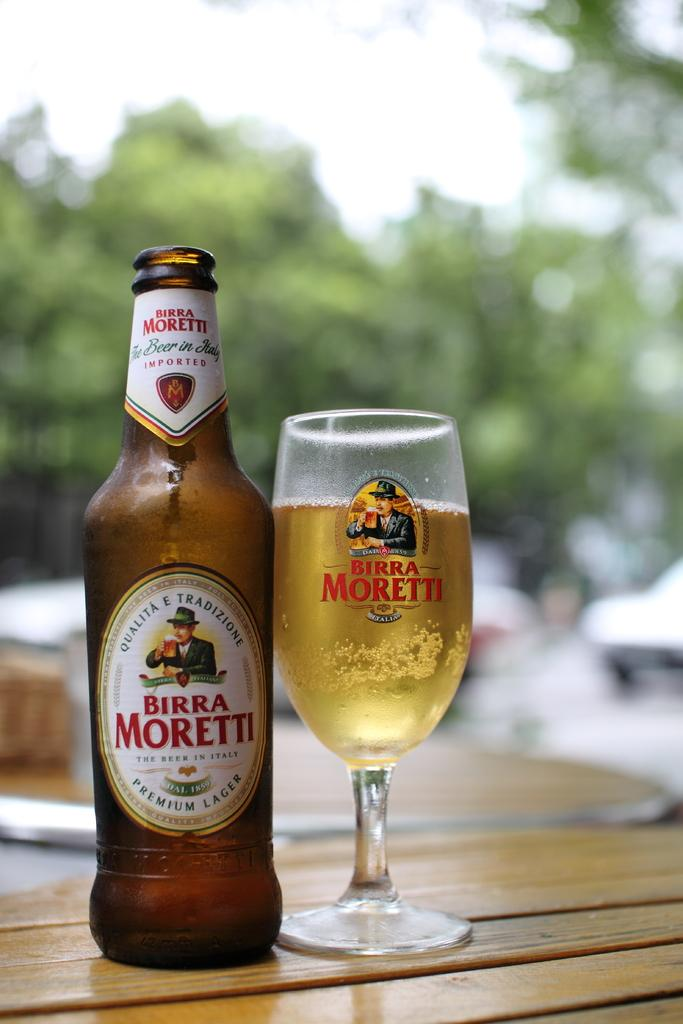<image>
Give a short and clear explanation of the subsequent image. A bottle of beer and a glass with the name Birra Moretti on them both 